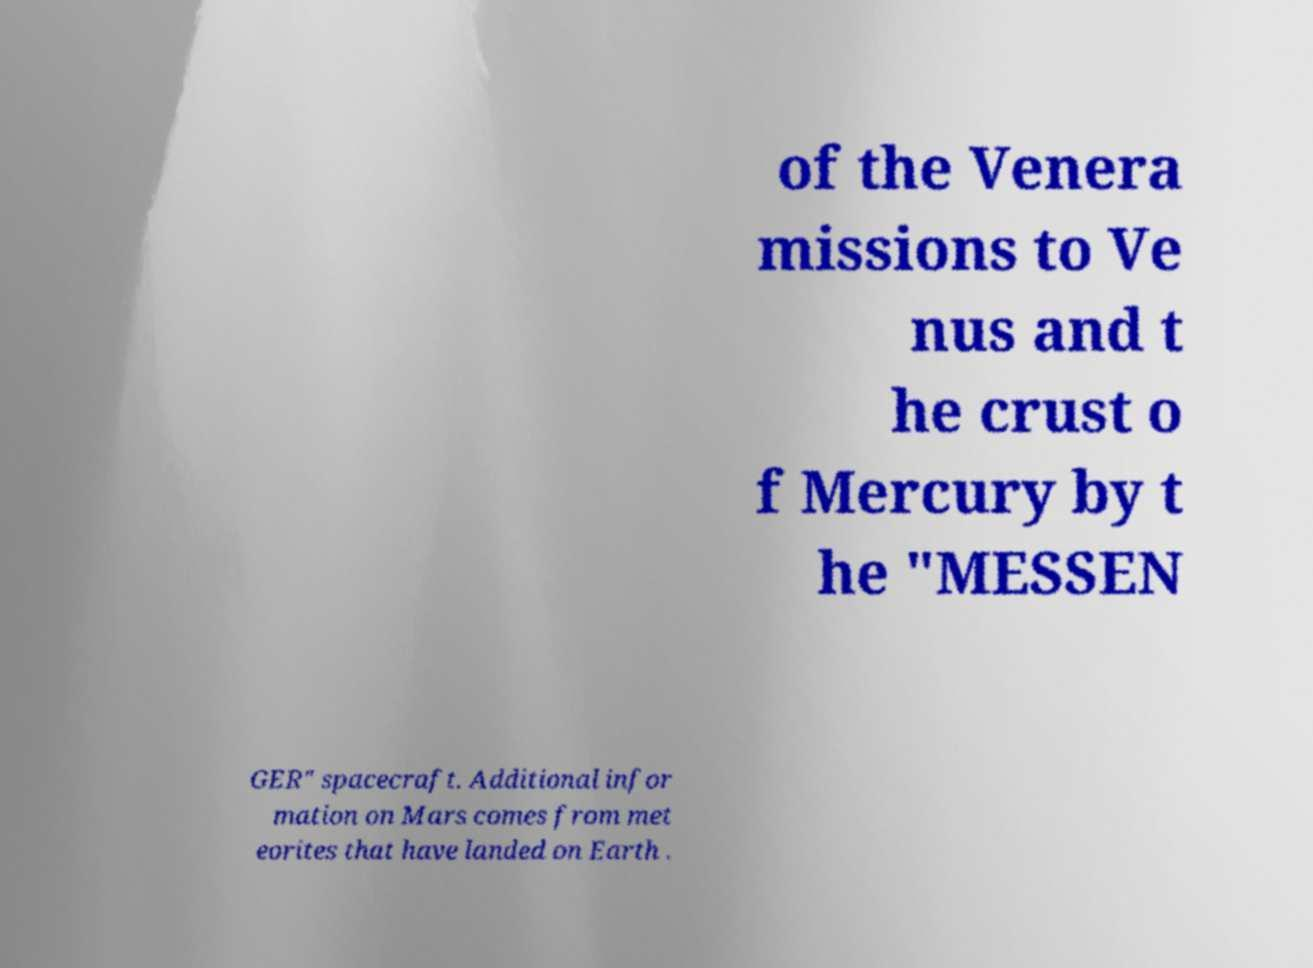I need the written content from this picture converted into text. Can you do that? of the Venera missions to Ve nus and t he crust o f Mercury by t he "MESSEN GER" spacecraft. Additional infor mation on Mars comes from met eorites that have landed on Earth . 